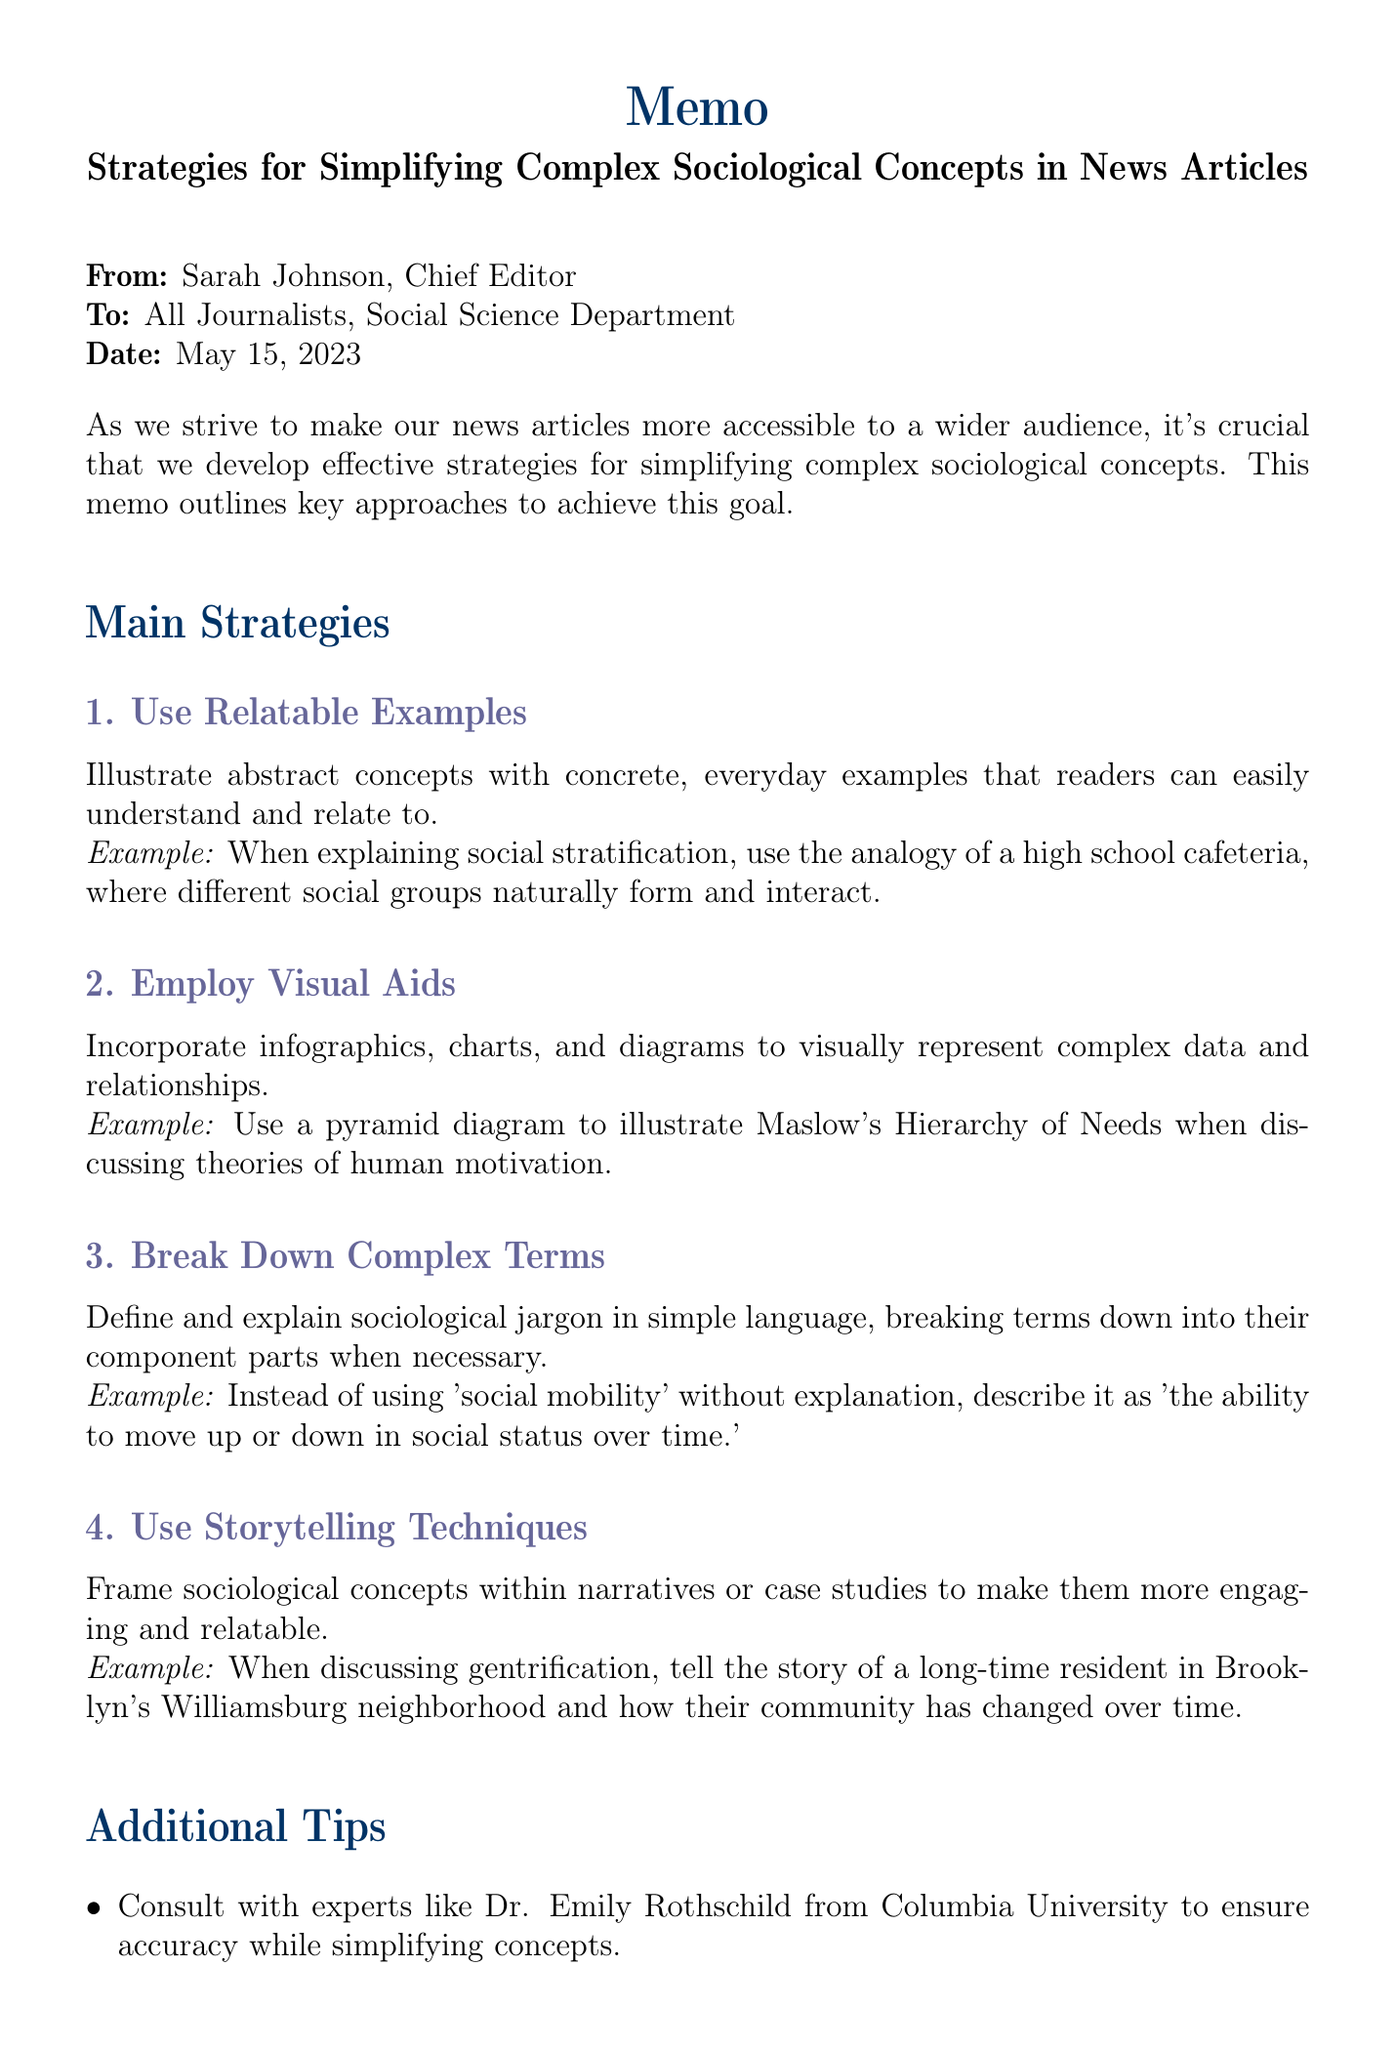what is the title of the memo? The title of the memo is provided at the beginning of the document and is "Strategies for Simplifying Complex Sociological Concepts in News Articles."
Answer: Strategies for Simplifying Complex Sociological Concepts in News Articles who is the memo addressed to? The memo is addressed to all journalists in the Social Science Department.
Answer: All Journalists, Social Science Department what is one of the main strategies recommended in the memo? One of the main strategies is listed under "Main Strategies," making it relatively easy to identify.
Answer: Use Relatable Examples which expert is suggested for consultation in the additional tips? The document mentions Dr. Emily Rothschild as an expert for consultation.
Answer: Dr. Emily Rothschild what is the date of the memo? The date is explicitly mentioned in the header of the document.
Answer: May 15, 2023 how many action items are listed in the memo? The number of action items is provided in the section labeled "Action Items."
Answer: Three what is the purpose of incorporating visual aids according to the memo? This purpose can be found in the description of the strategy related to visual aids.
Answer: To visually represent complex data and relationships how should complex terms be handled according to the memo? The memo suggests a specific approach to dealing with complex terms.
Answer: Break Down Complex Terms what type of narrative technique is encouraged in the memo? The document specifies a unique narrative approach outlined in the strategies section.
Answer: Use Storytelling Techniques 